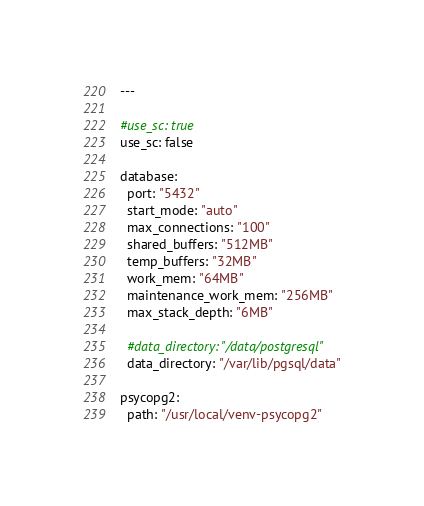Convert code to text. <code><loc_0><loc_0><loc_500><loc_500><_YAML_>---

#use_sc: true
use_sc: false

database:
  port: "5432"
  start_mode: "auto"
  max_connections: "100"
  shared_buffers: "512MB"
  temp_buffers: "32MB"
  work_mem: "64MB"
  maintenance_work_mem: "256MB"
  max_stack_depth: "6MB"

  #data_directory: "/data/postgresql"
  data_directory: "/var/lib/pgsql/data"

psycopg2:
  path: "/usr/local/venv-psycopg2"
</code> 